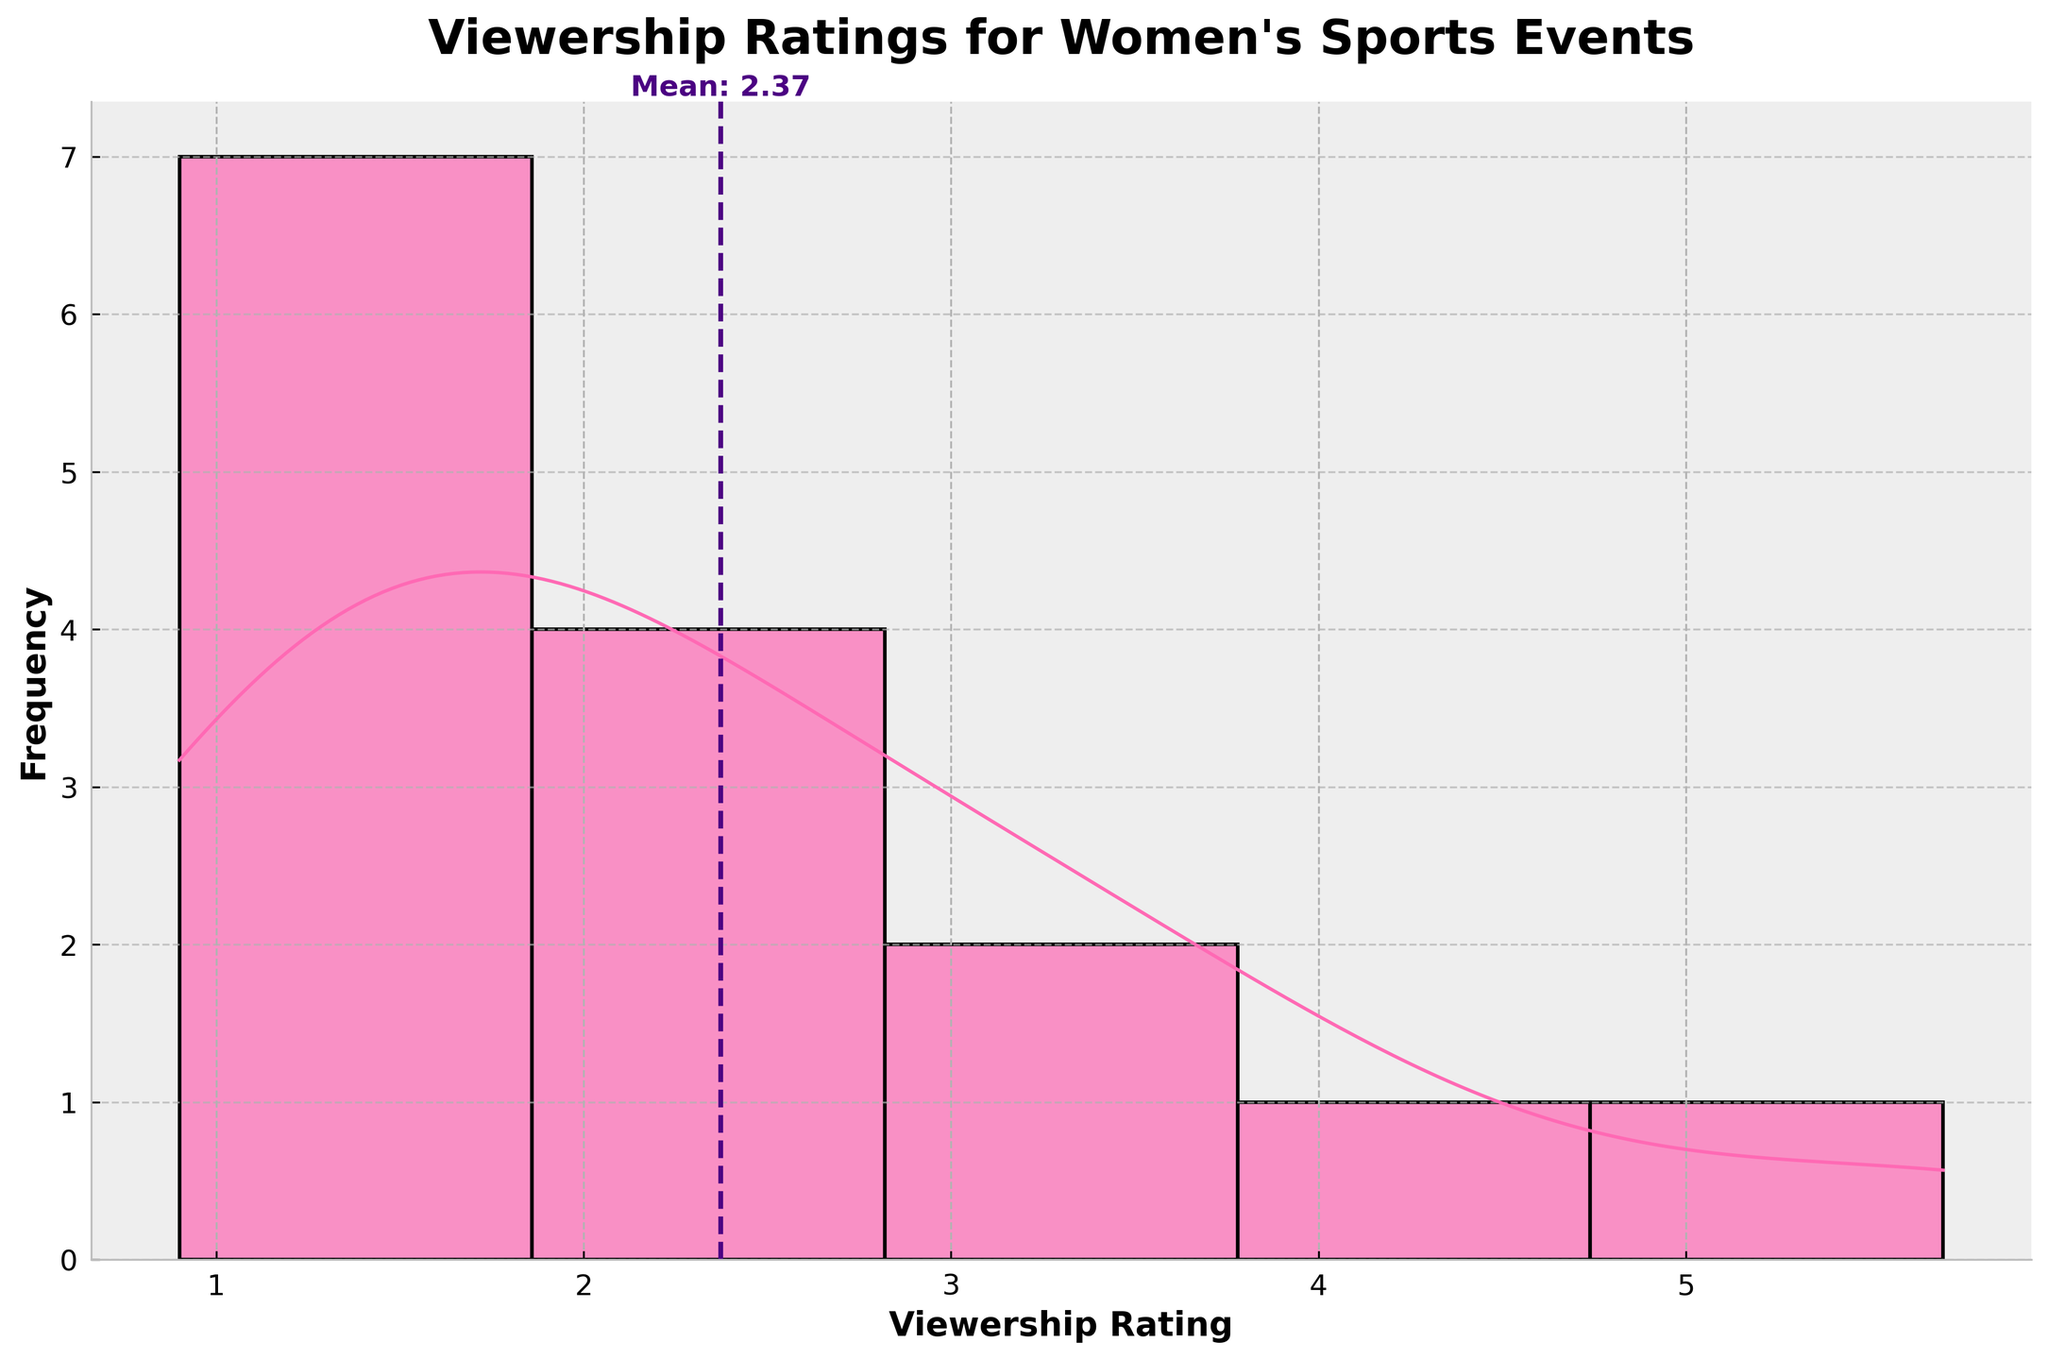Which time slot has the highest mean viewership rating? The mean line is a dashed vertical line. To identify the time slot with the highest mean, we need to inspect the average viewership ratings for each time slot. The position of the dashed mean line and the density curve helps in guessing the rough value for each time slot. Here, "Afternoon" has the highest density on the right side of the mean.
Answer: Afternoon What is the title of the figure? The title of the figure is displayed at the top of the chart.
Answer: "Viewership Ratings for Women's Sports Events" How many data points are there in total? The histogram bars represent different frequencies of viewership ratings. Counting the bars and summing their frequencies will give the total. The plot suggests 15 data points aligning with the original dataset.
Answer: 15 What is the approximate mean viewership rating? The mean viewership rating is indicated by a dashed vertical line, with an annotated label on the figure providing the exact value. The label shows that the mean is around 2.51.
Answer: 2.51 Which viewership rating is most common based on the density curve? The KDE (density curve) shows peaks where the data clusters around. The highest peak indicates the mode or most common value.
Answer: Around 2.5 Which viewership rating has the lowest density on the KDE curve? The lowest density on the KDE curve corresponds to the points where the curve is close to the horizontal axis, indicating sparse data.
Answer: Around 5.5 What is the range of viewership ratings shown in the histogram? The x-axis spans the range of viewership ratings. From the beginning to the end, it seems to range from 0 to approximately 6.
Answer: 0 to 6 Which time slot seems to have the lowest concentration of high viewership ratings? By looking at the histograms and KDE peaks, "Late Night" shows the lowest viewership ratings as its associated data points are clustered around lower values.
Answer: Late Night Is there a time slot with no viewership rating is greater than 3? Analyzing the histogram bars with respect to time slots, "Late Night" has no bars or peaks extending beyond the rating of 3.
Answer: Late Night 